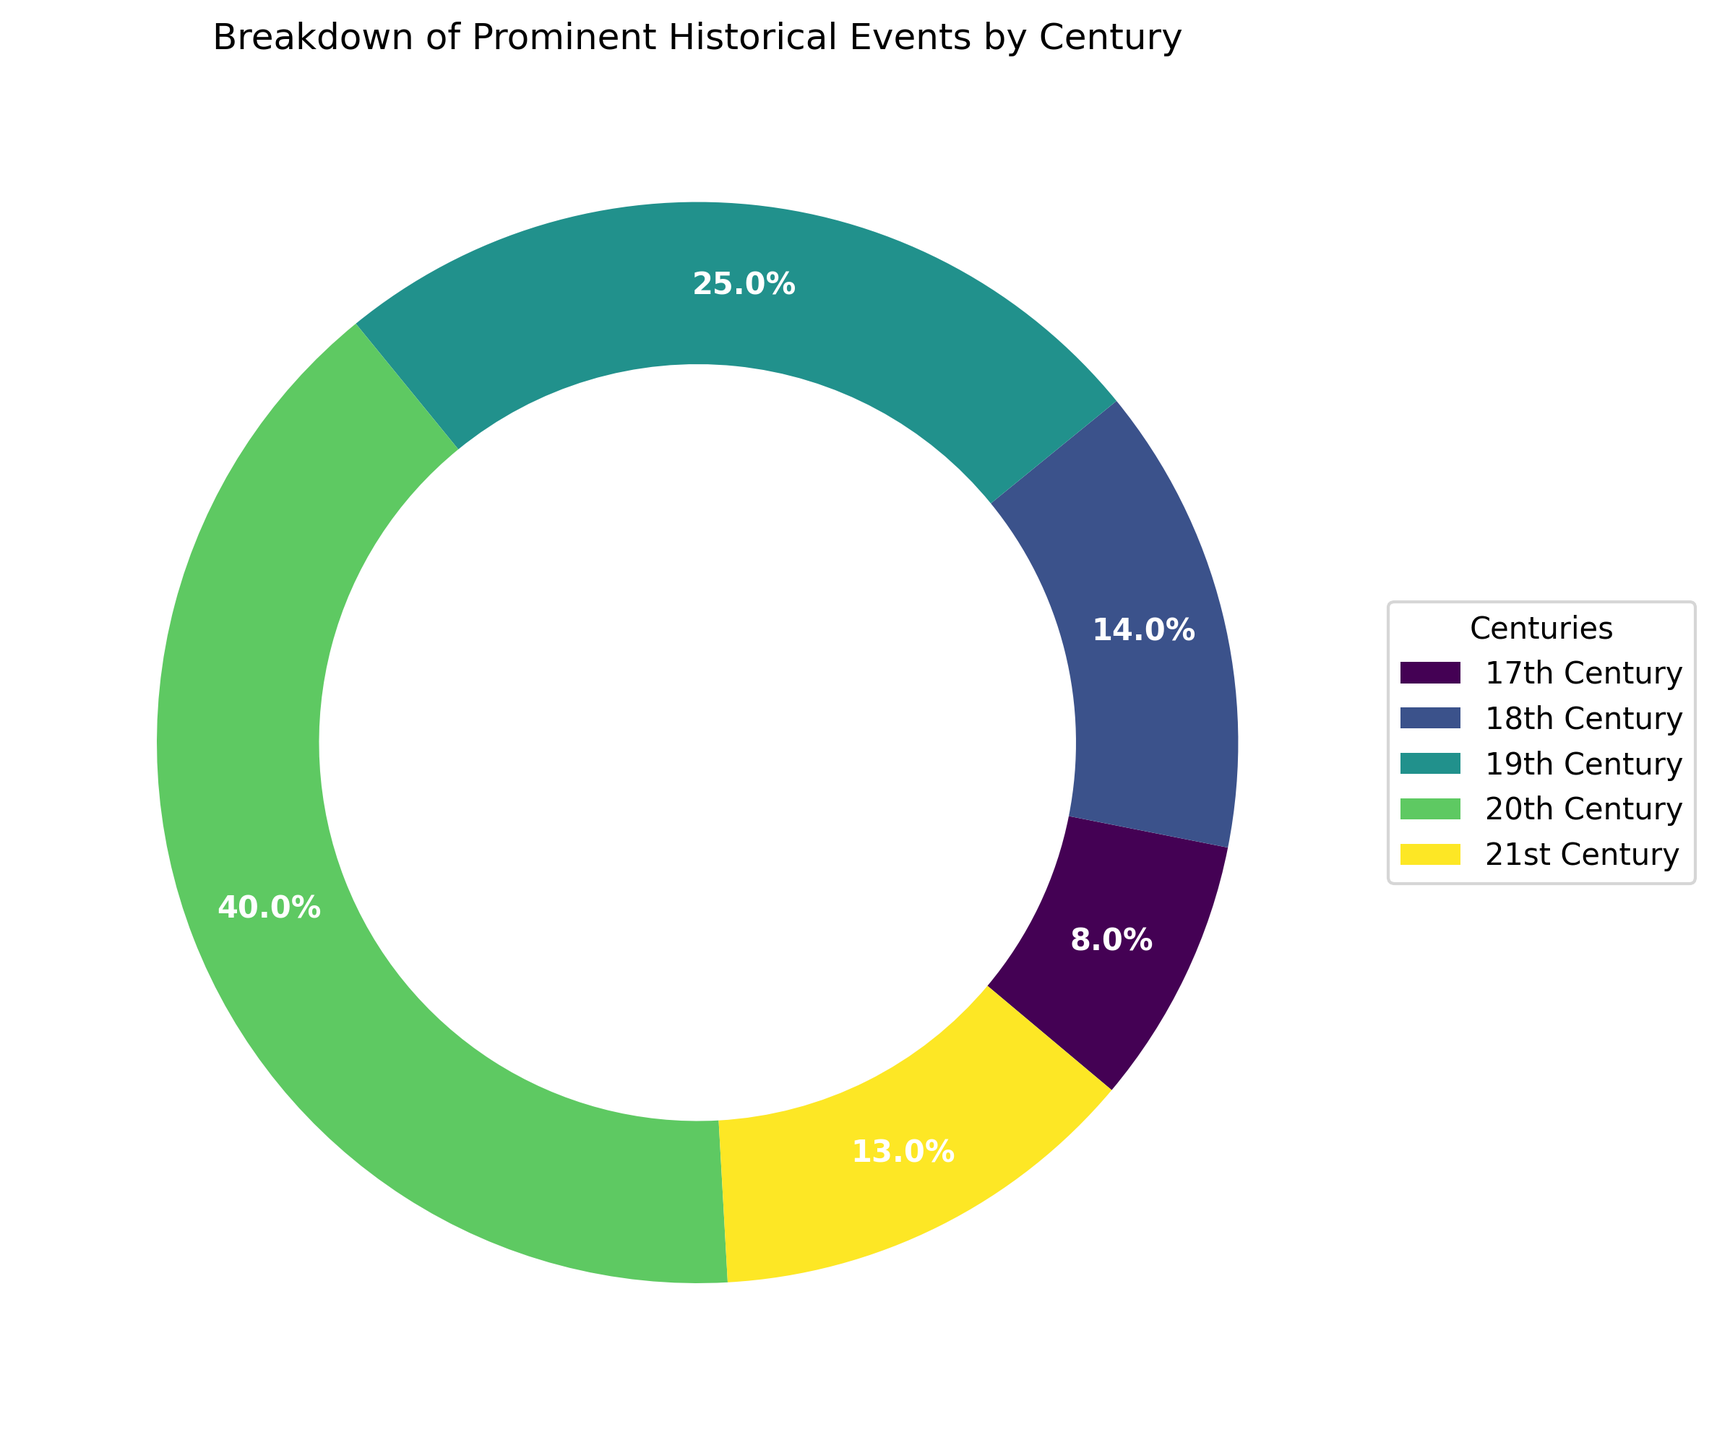Which century had the highest number of prominent historical events? The ring chart shows different segments representing various centuries with their proportional event counts. The largest portion corresponds to the 20th Century.
Answer: 20th Century What is the total number of prominent historical events from the 17th and 18th centuries? According to the chart, the 17th Century has 8 events and the 18th Century has 14 events. Adding these together yields 8 + 14 = 22.
Answer: 22 How many more historical events occurred in the 20th Century compared to the 21st Century? The chart indicates 40 events in the 20th Century and 13 events in the 21st Century. The difference is 40 - 13 = 27.
Answer: 27 What is the approximate percentage of historical events that took place in the 19th Century? The chart provides percentages for each century's events. The section for the 19th Century is labeled with approximately 25%.
Answer: 25% Which century had fewer prominent historical events: the 18th or the 21st Century? By observing the segments, the 18th Century has 14 events, while the 21st Century has 13 events. Therefore, the 21st Century had fewer events.
Answer: 21st Century What is the average number of events per century across all provided data? Summing the event counts for all centuries gives 8 + 14 + 25 + 40 + 13 = 100 events. Dividing by the number of centuries (5) gives an average of 100 / 5 = 20 events per century.
Answer: 20 Are there more prominent historical events in the 18th Century than in the 17th Century? According to the chart, the 18th Century has 14 events and the 17th Century has 8 events. Thus, the 18th Century had more events.
Answer: Yes What is the combined percentage of events from both the 19th and 21st Centuries? Based on the chart percentages, the 19th Century accounts for 25% and the 21st Century accounts for approximately 13%. Adding these gives 25% + 13% = 38%.
Answer: 38% Which century's events make up the smallest percentage of the total? The chart indicates that the 17th Century, comprising around 8% of the total events, represents the smallest segment.
Answer: 17th Century What is the difference in the percentage of events between the century with the most and the century with the fewest events? The 20th Century has the most events at 40%, while the 17th Century has the fewest at 8%. The difference is 40% - 8% = 32%.
Answer: 32% 